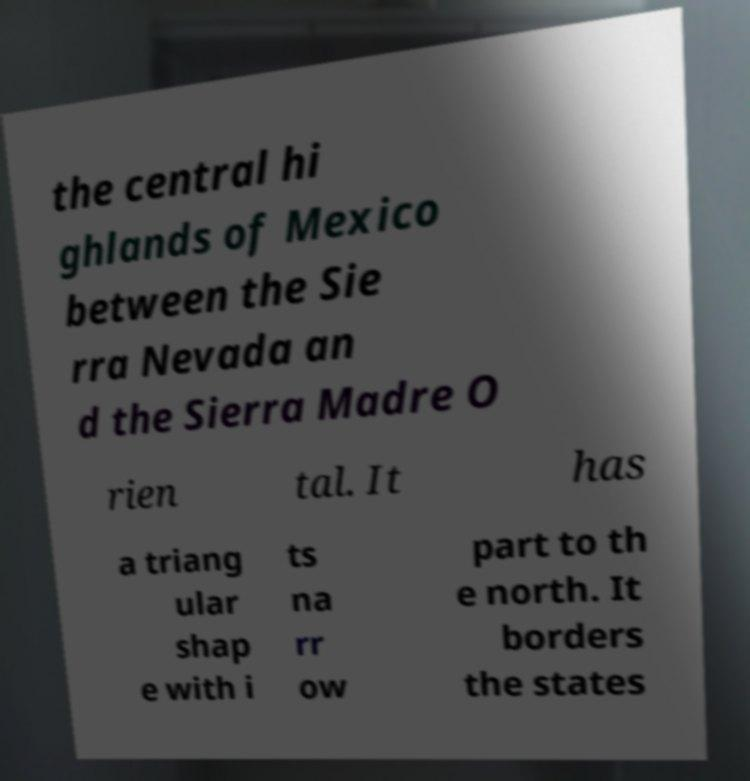There's text embedded in this image that I need extracted. Can you transcribe it verbatim? the central hi ghlands of Mexico between the Sie rra Nevada an d the Sierra Madre O rien tal. It has a triang ular shap e with i ts na rr ow part to th e north. It borders the states 